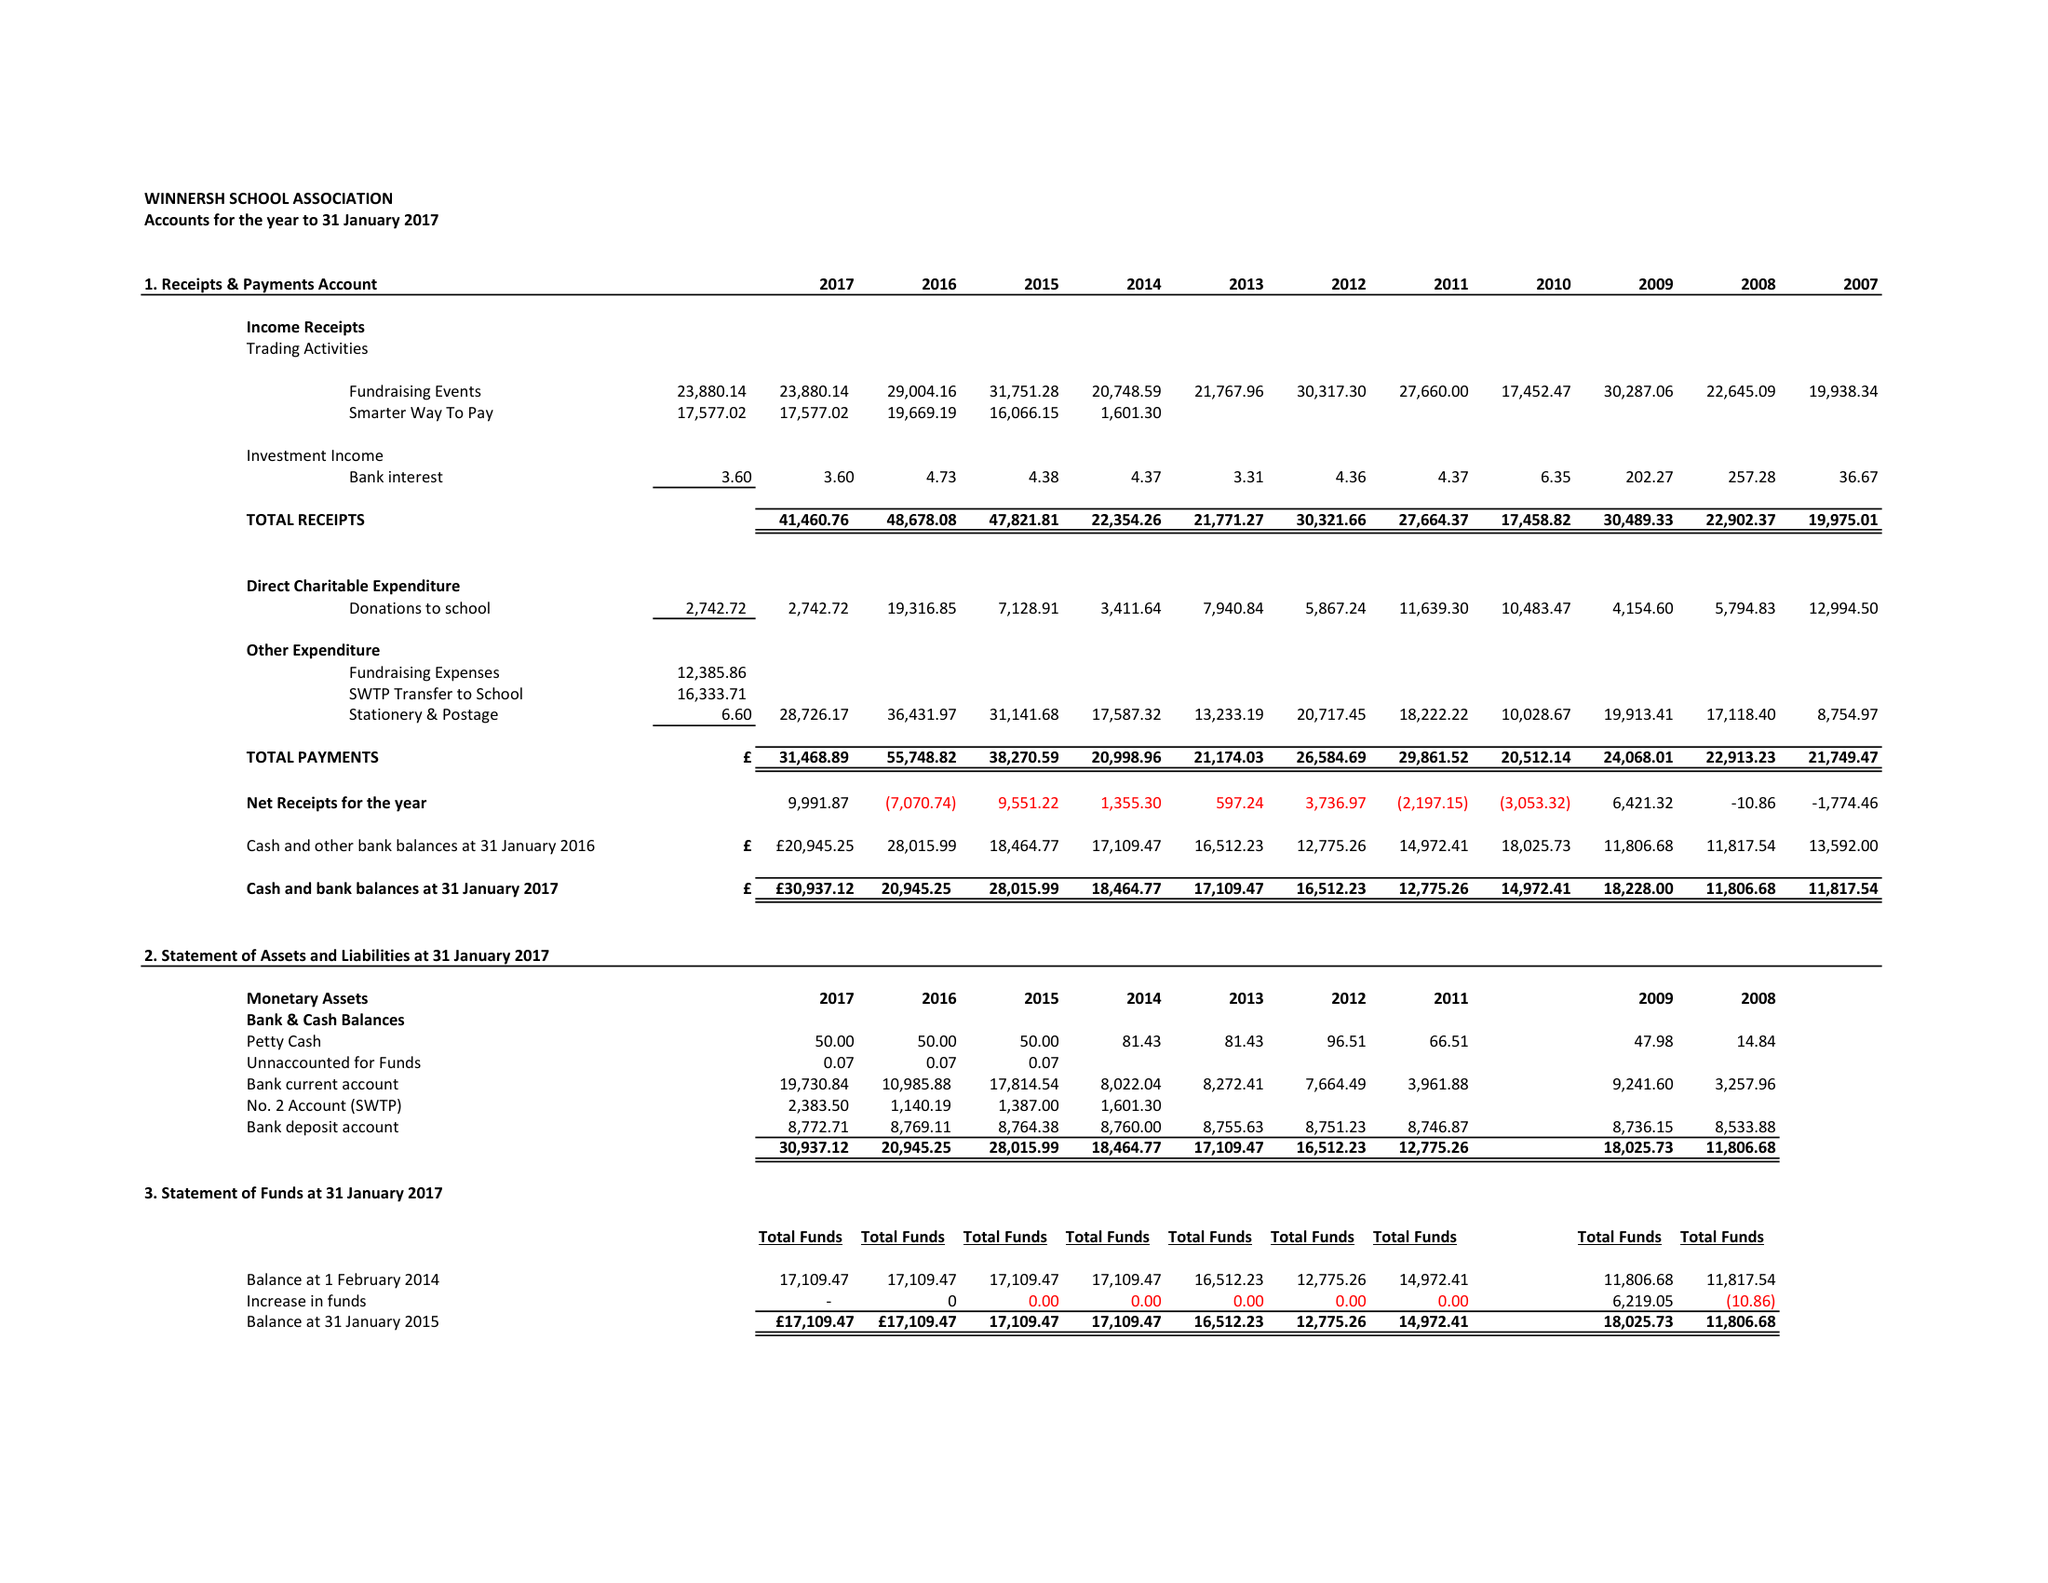What is the value for the spending_annually_in_british_pounds?
Answer the question using a single word or phrase. 31469.00 